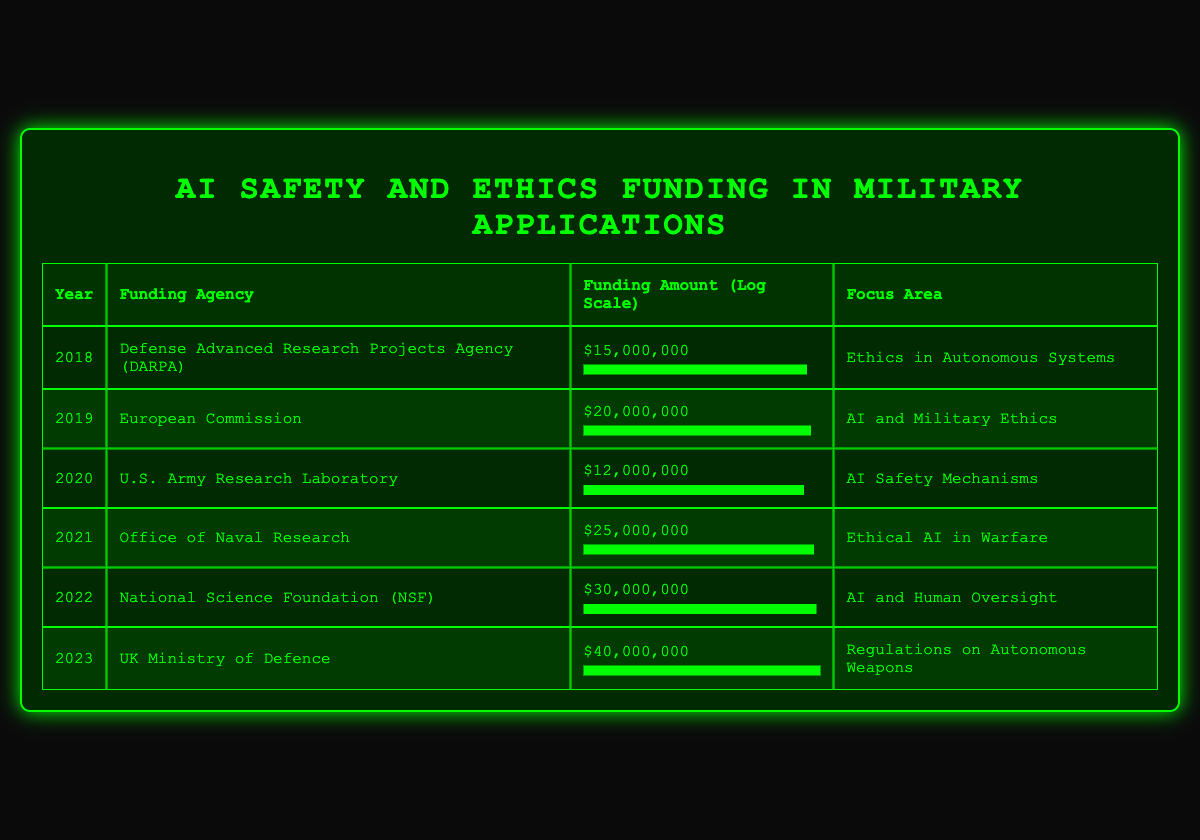What was the funding amount in 2021? In the table, under the year 2021, the funding agency is listed as the Office of Naval Research with a funding amount of $25,000,000.
Answer: $25,000,000 Which year saw the highest funding amount? The row for 2023 shows the highest funding amount at $40,000,000 for the UK Ministry of Defence.
Answer: 2023 What is the difference in funding amounts between 2018 and 2020? The funding amount for 2018 is $15,000,000 and for 2020 it is $12,000,000. The difference is calculated as $15,000,000 - $12,000,000 = $3,000,000.
Answer: $3,000,000 Is it true that the National Science Foundation provided the most funding in a single year? The National Science Foundation provided $30,000,000 in 2022, which is less than the UK Ministry of Defence in 2023, which provided $40,000,000. Therefore, it is false.
Answer: No What was the average funding amount from 2018 to 2023? The funding amounts from 2018 to 2023 are $15,000,000; $20,000,000; $12,000,000; $25,000,000; $30,000,000; and $40,000,000. The sum is $15,000,000 + $20,000,000 + $12,000,000 + $25,000,000 + $30,000,000 + $40,000,000 = $142,000,000. There are 6 years, so the average is $142,000,000 / 6 ≈ $23,666,667.
Answer: $23,666,667 Which agency focused on AI safety mechanisms and what was their funding? The U.S. Army Research Laboratory focused on AI Safety Mechanisms in 2020 with a funding amount of $12,000,000.
Answer: U.S. Army Research Laboratory, $12,000,000 